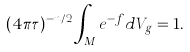<formula> <loc_0><loc_0><loc_500><loc_500>( 4 \pi \tau ) ^ { - n / 2 } \int _ { M } e ^ { - f } d V _ { g } = 1 .</formula> 